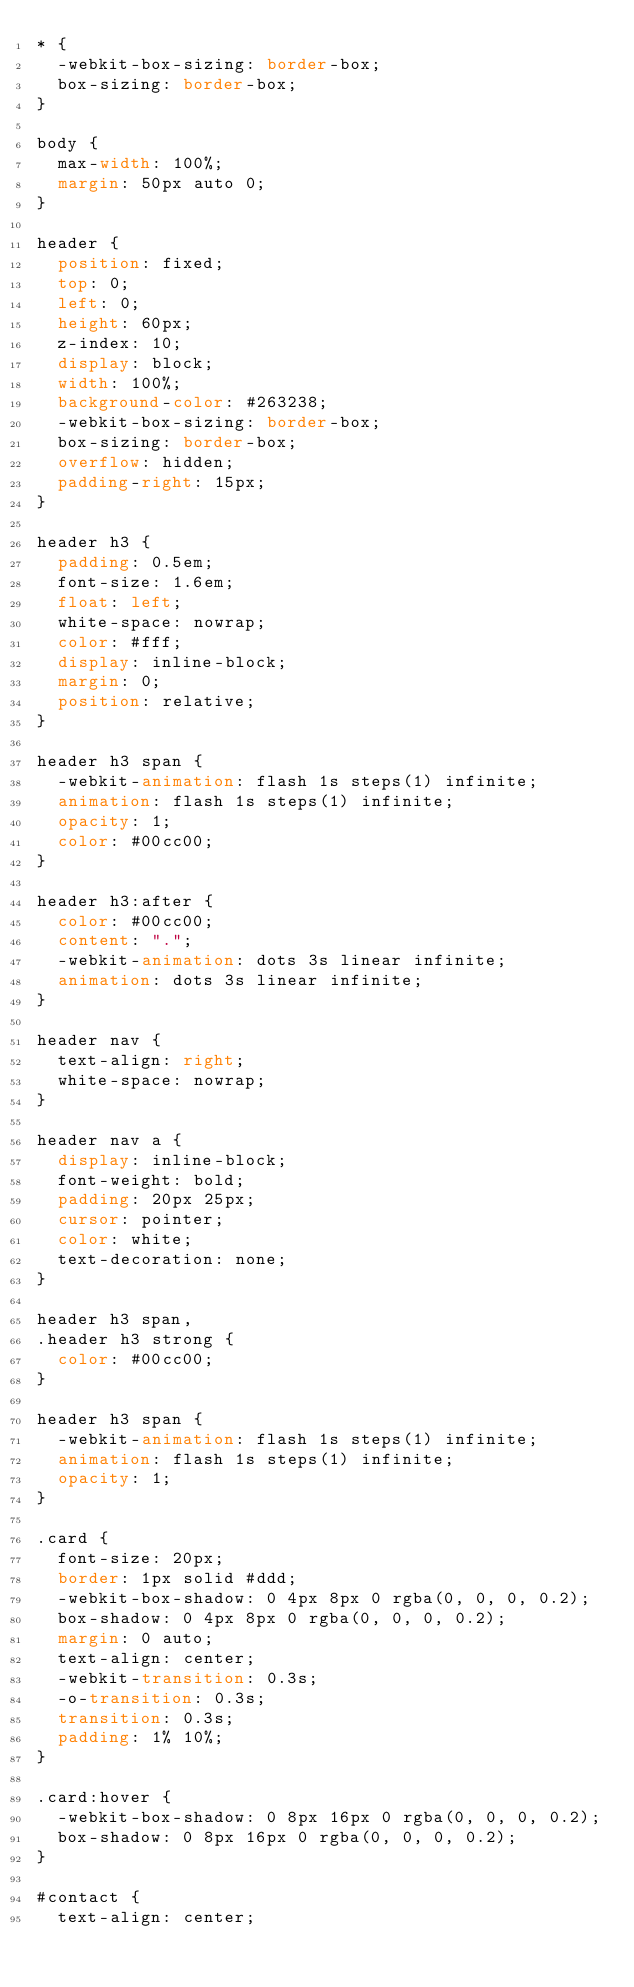<code> <loc_0><loc_0><loc_500><loc_500><_CSS_>* {
  -webkit-box-sizing: border-box;
  box-sizing: border-box;
}

body {
  max-width: 100%;
  margin: 50px auto 0;
}

header {
  position: fixed;
  top: 0;
  left: 0;
  height: 60px;
  z-index: 10;
  display: block;
  width: 100%;
  background-color: #263238;
  -webkit-box-sizing: border-box;
  box-sizing: border-box;
  overflow: hidden;
  padding-right: 15px;
}

header h3 {
  padding: 0.5em;
  font-size: 1.6em;
  float: left;
  white-space: nowrap;
  color: #fff;
  display: inline-block;
  margin: 0;
  position: relative;
}

header h3 span {
  -webkit-animation: flash 1s steps(1) infinite;
  animation: flash 1s steps(1) infinite;
  opacity: 1;
  color: #00cc00;
}

header h3:after {
  color: #00cc00;
  content: ".";
  -webkit-animation: dots 3s linear infinite;
  animation: dots 3s linear infinite;
}

header nav {
  text-align: right;
  white-space: nowrap;
}

header nav a {
  display: inline-block;
  font-weight: bold;
  padding: 20px 25px;
  cursor: pointer;
  color: white;
  text-decoration: none;
}

header h3 span,
.header h3 strong {
  color: #00cc00;
}

header h3 span {
  -webkit-animation: flash 1s steps(1) infinite;
  animation: flash 1s steps(1) infinite;
  opacity: 1;
}

.card {
  font-size: 20px;
  border: 1px solid #ddd;
  -webkit-box-shadow: 0 4px 8px 0 rgba(0, 0, 0, 0.2);
  box-shadow: 0 4px 8px 0 rgba(0, 0, 0, 0.2);
  margin: 0 auto;
  text-align: center;
  -webkit-transition: 0.3s;
  -o-transition: 0.3s;
  transition: 0.3s;
  padding: 1% 10%;
}

.card:hover {
  -webkit-box-shadow: 0 8px 16px 0 rgba(0, 0, 0, 0.2);
  box-shadow: 0 8px 16px 0 rgba(0, 0, 0, 0.2);
}

#contact {
  text-align: center;</code> 